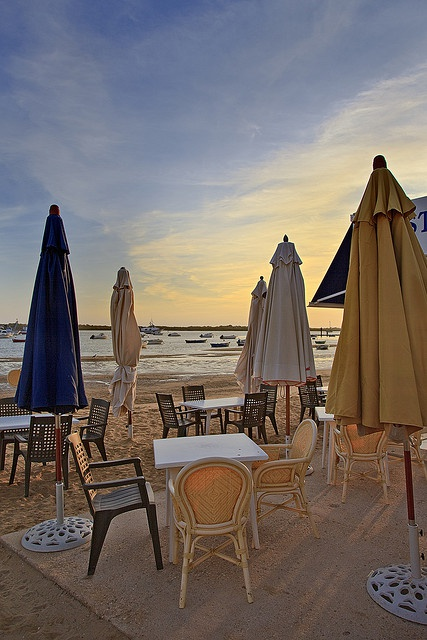Describe the objects in this image and their specific colors. I can see umbrella in gray, maroon, black, and olive tones, chair in gray, maroon, and black tones, umbrella in gray, black, navy, and maroon tones, umbrella in gray, maroon, and black tones, and dining table in gray, darkgray, and maroon tones in this image. 